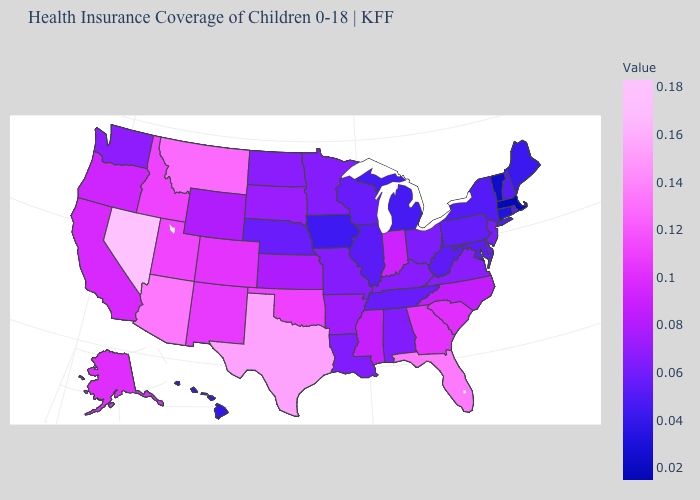Among the states that border Idaho , which have the highest value?
Short answer required. Nevada. Which states have the lowest value in the MidWest?
Keep it brief. Iowa. Which states have the highest value in the USA?
Give a very brief answer. Nevada. Which states hav the highest value in the MidWest?
Short answer required. Indiana. Which states hav the highest value in the West?
Write a very short answer. Nevada. Among the states that border Delaware , does Maryland have the highest value?
Short answer required. No. Does New Hampshire have a higher value than South Carolina?
Quick response, please. No. Does Pennsylvania have the lowest value in the USA?
Give a very brief answer. No. 